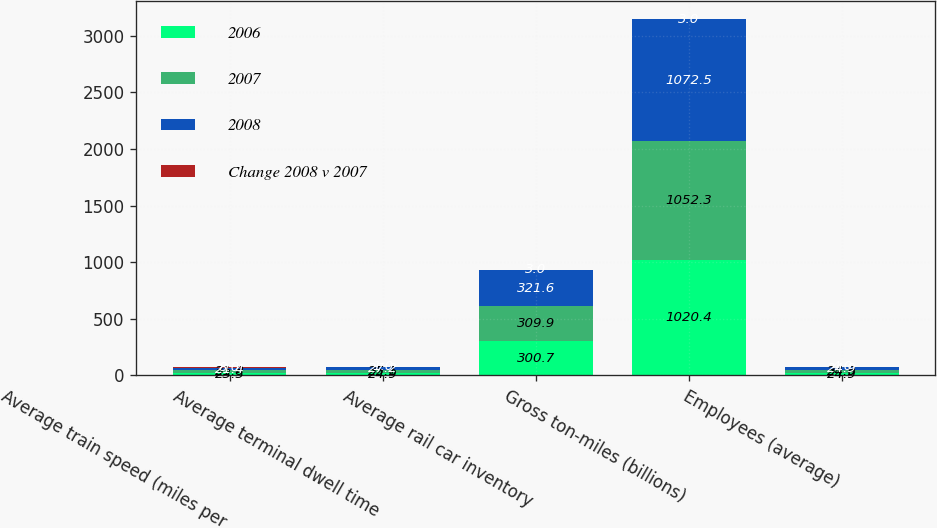<chart> <loc_0><loc_0><loc_500><loc_500><stacked_bar_chart><ecel><fcel>Average train speed (miles per<fcel>Average terminal dwell time<fcel>Average rail car inventory<fcel>Gross ton-miles (billions)<fcel>Employees (average)<nl><fcel>2006<fcel>23.5<fcel>24.9<fcel>300.7<fcel>1020.4<fcel>24.9<nl><fcel>2007<fcel>21.8<fcel>25.1<fcel>309.9<fcel>1052.3<fcel>24.9<nl><fcel>2008<fcel>21.4<fcel>27.2<fcel>321.6<fcel>1072.5<fcel>24.9<nl><fcel>Change 2008 v 2007<fcel>8<fcel>1<fcel>3<fcel>3<fcel>4<nl></chart> 